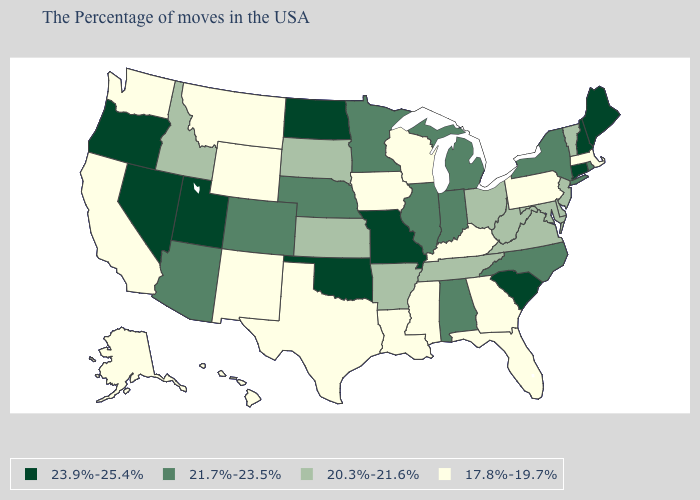What is the lowest value in the USA?
Quick response, please. 17.8%-19.7%. Name the states that have a value in the range 21.7%-23.5%?
Answer briefly. Rhode Island, New York, North Carolina, Michigan, Indiana, Alabama, Illinois, Minnesota, Nebraska, Colorado, Arizona. What is the value of Missouri?
Keep it brief. 23.9%-25.4%. What is the value of Pennsylvania?
Write a very short answer. 17.8%-19.7%. Name the states that have a value in the range 20.3%-21.6%?
Be succinct. Vermont, New Jersey, Delaware, Maryland, Virginia, West Virginia, Ohio, Tennessee, Arkansas, Kansas, South Dakota, Idaho. What is the highest value in states that border Florida?
Write a very short answer. 21.7%-23.5%. Name the states that have a value in the range 21.7%-23.5%?
Keep it brief. Rhode Island, New York, North Carolina, Michigan, Indiana, Alabama, Illinois, Minnesota, Nebraska, Colorado, Arizona. Does Utah have the highest value in the West?
Give a very brief answer. Yes. What is the value of Washington?
Answer briefly. 17.8%-19.7%. What is the value of New Mexico?
Concise answer only. 17.8%-19.7%. What is the value of Wisconsin?
Short answer required. 17.8%-19.7%. Name the states that have a value in the range 21.7%-23.5%?
Quick response, please. Rhode Island, New York, North Carolina, Michigan, Indiana, Alabama, Illinois, Minnesota, Nebraska, Colorado, Arizona. What is the value of Florida?
Give a very brief answer. 17.8%-19.7%. How many symbols are there in the legend?
Short answer required. 4. Does Oregon have the highest value in the West?
Write a very short answer. Yes. 